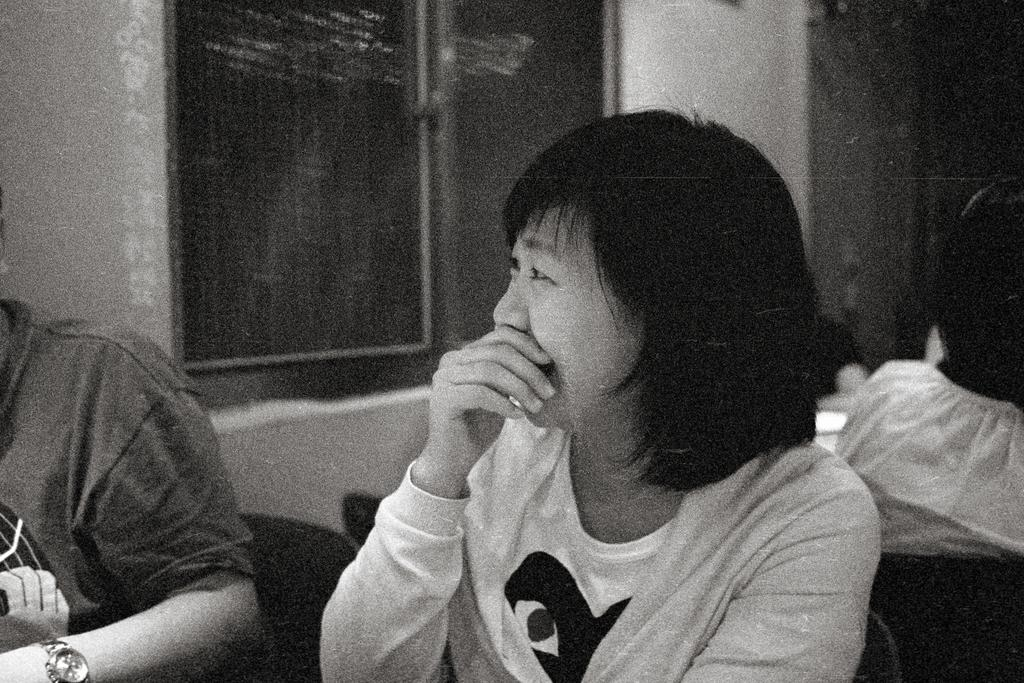How many people are present in the image? There are two persons in the image. What can be seen on the wall in the image? There is a wall with a window in the image. Can you describe the background of the image? There are people visible in the background of the image. What type of cheese is being used to decorate the neck of one of the persons in the image? There is no cheese present in the image, and no one's neck is being decorated with cheese. 